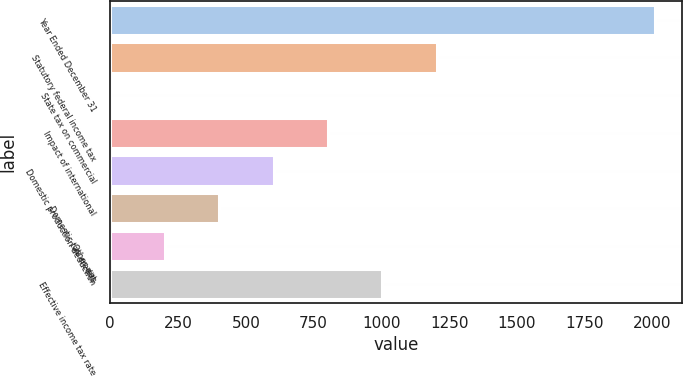<chart> <loc_0><loc_0><loc_500><loc_500><bar_chart><fcel>Year Ended December 31<fcel>Statutory federal income tax<fcel>State tax on commercial<fcel>Impact of international<fcel>Domestic production deduction<fcel>Domestic tax credits<fcel>Other net<fcel>Effective income tax rate<nl><fcel>2008<fcel>1204.84<fcel>0.1<fcel>803.26<fcel>602.47<fcel>401.68<fcel>200.89<fcel>1004.05<nl></chart> 